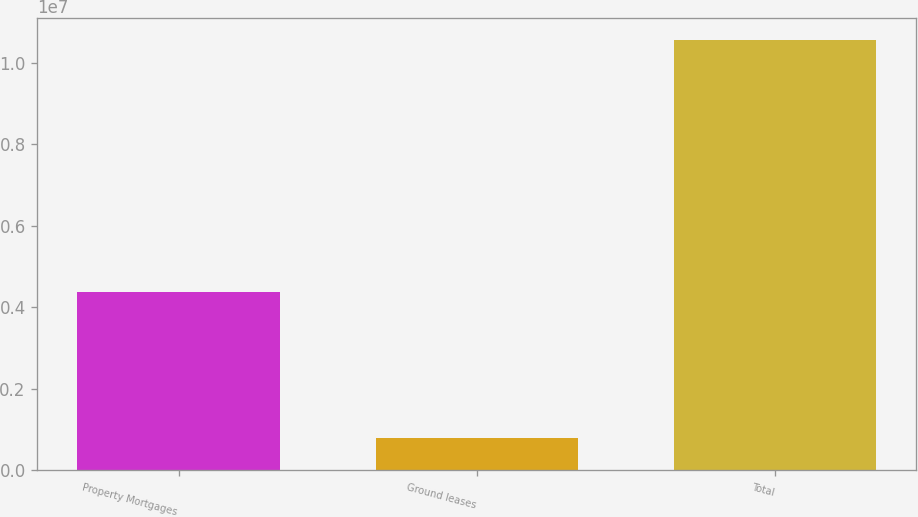Convert chart to OTSL. <chart><loc_0><loc_0><loc_500><loc_500><bar_chart><fcel>Property Mortgages<fcel>Ground leases<fcel>Total<nl><fcel>4.37384e+06<fcel>782699<fcel>1.05707e+07<nl></chart> 